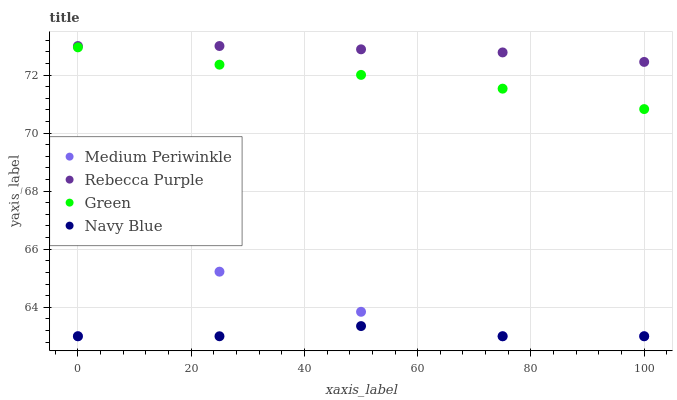Does Navy Blue have the minimum area under the curve?
Answer yes or no. Yes. Does Rebecca Purple have the maximum area under the curve?
Answer yes or no. Yes. Does Medium Periwinkle have the minimum area under the curve?
Answer yes or no. No. Does Medium Periwinkle have the maximum area under the curve?
Answer yes or no. No. Is Rebecca Purple the smoothest?
Answer yes or no. Yes. Is Medium Periwinkle the roughest?
Answer yes or no. Yes. Is Medium Periwinkle the smoothest?
Answer yes or no. No. Is Rebecca Purple the roughest?
Answer yes or no. No. Does Medium Periwinkle have the lowest value?
Answer yes or no. Yes. Does Rebecca Purple have the lowest value?
Answer yes or no. No. Does Rebecca Purple have the highest value?
Answer yes or no. Yes. Does Medium Periwinkle have the highest value?
Answer yes or no. No. Is Medium Periwinkle less than Green?
Answer yes or no. Yes. Is Rebecca Purple greater than Navy Blue?
Answer yes or no. Yes. Does Navy Blue intersect Medium Periwinkle?
Answer yes or no. Yes. Is Navy Blue less than Medium Periwinkle?
Answer yes or no. No. Is Navy Blue greater than Medium Periwinkle?
Answer yes or no. No. Does Medium Periwinkle intersect Green?
Answer yes or no. No. 